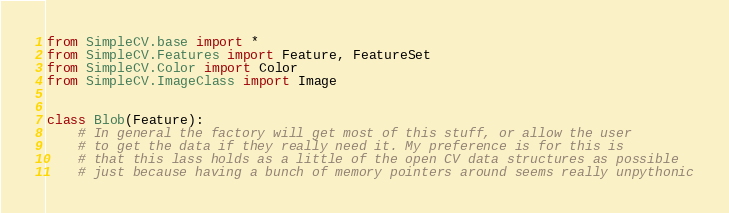<code> <loc_0><loc_0><loc_500><loc_500><_Python_>from SimpleCV.base import *
from SimpleCV.Features import Feature, FeatureSet
from SimpleCV.Color import Color
from SimpleCV.ImageClass import Image


class Blob(Feature):
    # In general the factory will get most of this stuff, or allow the user
    # to get the data if they really need it. My preference is for this is
    # that this lass holds as a little of the open CV data structures as possible
    # just because having a bunch of memory pointers around seems really unpythonic</code> 